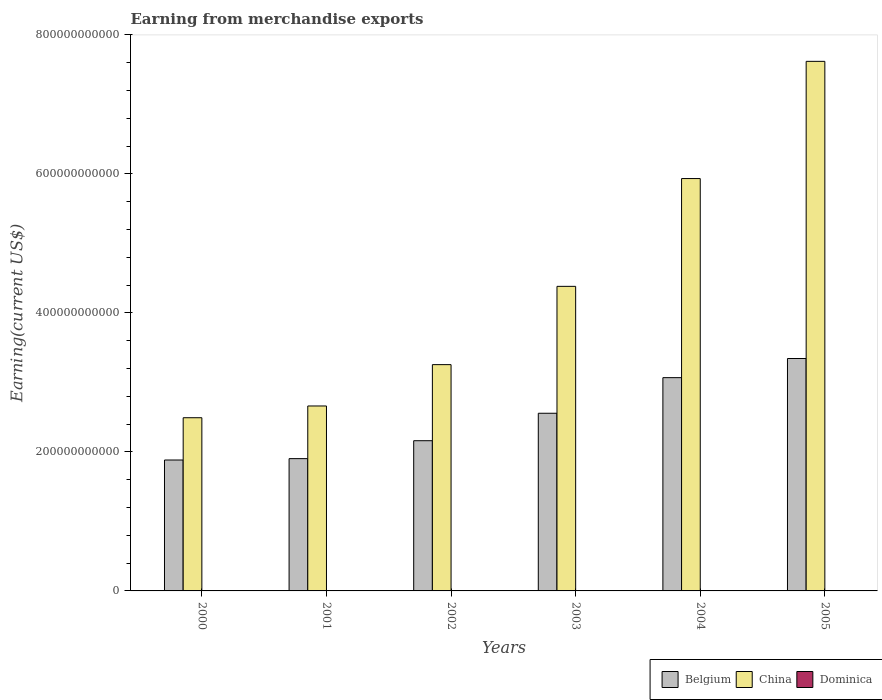How many different coloured bars are there?
Your answer should be compact. 3. How many groups of bars are there?
Give a very brief answer. 6. How many bars are there on the 2nd tick from the left?
Keep it short and to the point. 3. In how many cases, is the number of bars for a given year not equal to the number of legend labels?
Provide a short and direct response. 0. What is the amount earned from merchandise exports in China in 2001?
Your answer should be compact. 2.66e+11. Across all years, what is the maximum amount earned from merchandise exports in Dominica?
Give a very brief answer. 5.30e+07. Across all years, what is the minimum amount earned from merchandise exports in China?
Ensure brevity in your answer.  2.49e+11. In which year was the amount earned from merchandise exports in Belgium minimum?
Offer a terse response. 2000. What is the total amount earned from merchandise exports in Dominica in the graph?
Offer a terse response. 2.64e+08. What is the difference between the amount earned from merchandise exports in China in 2001 and that in 2005?
Give a very brief answer. -4.96e+11. What is the difference between the amount earned from merchandise exports in Belgium in 2001 and the amount earned from merchandise exports in Dominica in 2004?
Give a very brief answer. 1.90e+11. What is the average amount earned from merchandise exports in China per year?
Give a very brief answer. 4.39e+11. In the year 2002, what is the difference between the amount earned from merchandise exports in Dominica and amount earned from merchandise exports in Belgium?
Keep it short and to the point. -2.16e+11. What is the ratio of the amount earned from merchandise exports in Belgium in 2000 to that in 2005?
Keep it short and to the point. 0.56. What is the difference between the highest and the second highest amount earned from merchandise exports in Belgium?
Your answer should be very brief. 2.75e+1. What is the difference between the highest and the lowest amount earned from merchandise exports in China?
Provide a succinct answer. 5.13e+11. In how many years, is the amount earned from merchandise exports in Belgium greater than the average amount earned from merchandise exports in Belgium taken over all years?
Provide a succinct answer. 3. Is the sum of the amount earned from merchandise exports in China in 2001 and 2003 greater than the maximum amount earned from merchandise exports in Dominica across all years?
Ensure brevity in your answer.  Yes. What does the 3rd bar from the left in 2004 represents?
Keep it short and to the point. Dominica. What does the 3rd bar from the right in 2000 represents?
Give a very brief answer. Belgium. How many bars are there?
Your response must be concise. 18. How many years are there in the graph?
Make the answer very short. 6. What is the difference between two consecutive major ticks on the Y-axis?
Your answer should be very brief. 2.00e+11. Are the values on the major ticks of Y-axis written in scientific E-notation?
Your answer should be compact. No. Does the graph contain grids?
Give a very brief answer. No. Where does the legend appear in the graph?
Provide a short and direct response. Bottom right. How many legend labels are there?
Offer a terse response. 3. What is the title of the graph?
Provide a succinct answer. Earning from merchandise exports. What is the label or title of the Y-axis?
Offer a terse response. Earning(current US$). What is the Earning(current US$) of Belgium in 2000?
Your answer should be very brief. 1.88e+11. What is the Earning(current US$) of China in 2000?
Your answer should be very brief. 2.49e+11. What is the Earning(current US$) in Dominica in 2000?
Your response must be concise. 5.30e+07. What is the Earning(current US$) of Belgium in 2001?
Make the answer very short. 1.90e+11. What is the Earning(current US$) of China in 2001?
Keep it short and to the point. 2.66e+11. What is the Earning(current US$) in Dominica in 2001?
Your answer should be compact. 4.40e+07. What is the Earning(current US$) of Belgium in 2002?
Offer a very short reply. 2.16e+11. What is the Earning(current US$) of China in 2002?
Provide a succinct answer. 3.26e+11. What is the Earning(current US$) of Dominica in 2002?
Your answer should be very brief. 4.30e+07. What is the Earning(current US$) in Belgium in 2003?
Keep it short and to the point. 2.56e+11. What is the Earning(current US$) of China in 2003?
Offer a terse response. 4.38e+11. What is the Earning(current US$) in Dominica in 2003?
Provide a short and direct response. 4.00e+07. What is the Earning(current US$) of Belgium in 2004?
Provide a short and direct response. 3.07e+11. What is the Earning(current US$) of China in 2004?
Provide a short and direct response. 5.93e+11. What is the Earning(current US$) in Dominica in 2004?
Make the answer very short. 4.20e+07. What is the Earning(current US$) in Belgium in 2005?
Offer a terse response. 3.34e+11. What is the Earning(current US$) in China in 2005?
Offer a terse response. 7.62e+11. What is the Earning(current US$) of Dominica in 2005?
Offer a very short reply. 4.18e+07. Across all years, what is the maximum Earning(current US$) in Belgium?
Offer a terse response. 3.34e+11. Across all years, what is the maximum Earning(current US$) of China?
Your answer should be compact. 7.62e+11. Across all years, what is the maximum Earning(current US$) of Dominica?
Make the answer very short. 5.30e+07. Across all years, what is the minimum Earning(current US$) in Belgium?
Provide a short and direct response. 1.88e+11. Across all years, what is the minimum Earning(current US$) in China?
Your answer should be compact. 2.49e+11. Across all years, what is the minimum Earning(current US$) in Dominica?
Ensure brevity in your answer.  4.00e+07. What is the total Earning(current US$) of Belgium in the graph?
Provide a succinct answer. 1.49e+12. What is the total Earning(current US$) in China in the graph?
Give a very brief answer. 2.63e+12. What is the total Earning(current US$) of Dominica in the graph?
Provide a succinct answer. 2.64e+08. What is the difference between the Earning(current US$) of Belgium in 2000 and that in 2001?
Give a very brief answer. -1.98e+09. What is the difference between the Earning(current US$) in China in 2000 and that in 2001?
Ensure brevity in your answer.  -1.69e+1. What is the difference between the Earning(current US$) in Dominica in 2000 and that in 2001?
Your answer should be very brief. 9.00e+06. What is the difference between the Earning(current US$) of Belgium in 2000 and that in 2002?
Your answer should be very brief. -2.78e+1. What is the difference between the Earning(current US$) of China in 2000 and that in 2002?
Your answer should be very brief. -7.64e+1. What is the difference between the Earning(current US$) of Dominica in 2000 and that in 2002?
Your answer should be compact. 1.00e+07. What is the difference between the Earning(current US$) of Belgium in 2000 and that in 2003?
Provide a succinct answer. -6.72e+1. What is the difference between the Earning(current US$) in China in 2000 and that in 2003?
Your answer should be compact. -1.89e+11. What is the difference between the Earning(current US$) of Dominica in 2000 and that in 2003?
Ensure brevity in your answer.  1.30e+07. What is the difference between the Earning(current US$) in Belgium in 2000 and that in 2004?
Offer a very short reply. -1.18e+11. What is the difference between the Earning(current US$) in China in 2000 and that in 2004?
Ensure brevity in your answer.  -3.44e+11. What is the difference between the Earning(current US$) in Dominica in 2000 and that in 2004?
Your response must be concise. 1.10e+07. What is the difference between the Earning(current US$) in Belgium in 2000 and that in 2005?
Offer a very short reply. -1.46e+11. What is the difference between the Earning(current US$) in China in 2000 and that in 2005?
Keep it short and to the point. -5.13e+11. What is the difference between the Earning(current US$) in Dominica in 2000 and that in 2005?
Make the answer very short. 1.12e+07. What is the difference between the Earning(current US$) in Belgium in 2001 and that in 2002?
Keep it short and to the point. -2.58e+1. What is the difference between the Earning(current US$) in China in 2001 and that in 2002?
Offer a very short reply. -5.95e+1. What is the difference between the Earning(current US$) in Dominica in 2001 and that in 2002?
Offer a terse response. 1.00e+06. What is the difference between the Earning(current US$) in Belgium in 2001 and that in 2003?
Make the answer very short. -6.53e+1. What is the difference between the Earning(current US$) in China in 2001 and that in 2003?
Your answer should be compact. -1.72e+11. What is the difference between the Earning(current US$) in Dominica in 2001 and that in 2003?
Your answer should be compact. 4.00e+06. What is the difference between the Earning(current US$) in Belgium in 2001 and that in 2004?
Make the answer very short. -1.17e+11. What is the difference between the Earning(current US$) of China in 2001 and that in 2004?
Your answer should be compact. -3.27e+11. What is the difference between the Earning(current US$) of Dominica in 2001 and that in 2004?
Keep it short and to the point. 2.00e+06. What is the difference between the Earning(current US$) of Belgium in 2001 and that in 2005?
Your response must be concise. -1.44e+11. What is the difference between the Earning(current US$) of China in 2001 and that in 2005?
Ensure brevity in your answer.  -4.96e+11. What is the difference between the Earning(current US$) of Dominica in 2001 and that in 2005?
Offer a terse response. 2.22e+06. What is the difference between the Earning(current US$) in Belgium in 2002 and that in 2003?
Provide a short and direct response. -3.95e+1. What is the difference between the Earning(current US$) of China in 2002 and that in 2003?
Your response must be concise. -1.13e+11. What is the difference between the Earning(current US$) in Dominica in 2002 and that in 2003?
Your response must be concise. 3.00e+06. What is the difference between the Earning(current US$) of Belgium in 2002 and that in 2004?
Provide a short and direct response. -9.07e+1. What is the difference between the Earning(current US$) of China in 2002 and that in 2004?
Provide a succinct answer. -2.68e+11. What is the difference between the Earning(current US$) in Dominica in 2002 and that in 2004?
Provide a succinct answer. 1.00e+06. What is the difference between the Earning(current US$) of Belgium in 2002 and that in 2005?
Provide a succinct answer. -1.18e+11. What is the difference between the Earning(current US$) in China in 2002 and that in 2005?
Give a very brief answer. -4.36e+11. What is the difference between the Earning(current US$) of Dominica in 2002 and that in 2005?
Your answer should be compact. 1.22e+06. What is the difference between the Earning(current US$) in Belgium in 2003 and that in 2004?
Provide a short and direct response. -5.12e+1. What is the difference between the Earning(current US$) in China in 2003 and that in 2004?
Provide a short and direct response. -1.55e+11. What is the difference between the Earning(current US$) in Dominica in 2003 and that in 2004?
Provide a succinct answer. -1.99e+06. What is the difference between the Earning(current US$) in Belgium in 2003 and that in 2005?
Provide a short and direct response. -7.88e+1. What is the difference between the Earning(current US$) in China in 2003 and that in 2005?
Offer a very short reply. -3.24e+11. What is the difference between the Earning(current US$) of Dominica in 2003 and that in 2005?
Your answer should be very brief. -1.78e+06. What is the difference between the Earning(current US$) of Belgium in 2004 and that in 2005?
Ensure brevity in your answer.  -2.75e+1. What is the difference between the Earning(current US$) in China in 2004 and that in 2005?
Your response must be concise. -1.69e+11. What is the difference between the Earning(current US$) of Dominica in 2004 and that in 2005?
Provide a short and direct response. 2.12e+05. What is the difference between the Earning(current US$) in Belgium in 2000 and the Earning(current US$) in China in 2001?
Make the answer very short. -7.77e+1. What is the difference between the Earning(current US$) in Belgium in 2000 and the Earning(current US$) in Dominica in 2001?
Offer a very short reply. 1.88e+11. What is the difference between the Earning(current US$) in China in 2000 and the Earning(current US$) in Dominica in 2001?
Your response must be concise. 2.49e+11. What is the difference between the Earning(current US$) in Belgium in 2000 and the Earning(current US$) in China in 2002?
Offer a very short reply. -1.37e+11. What is the difference between the Earning(current US$) in Belgium in 2000 and the Earning(current US$) in Dominica in 2002?
Give a very brief answer. 1.88e+11. What is the difference between the Earning(current US$) in China in 2000 and the Earning(current US$) in Dominica in 2002?
Your answer should be compact. 2.49e+11. What is the difference between the Earning(current US$) of Belgium in 2000 and the Earning(current US$) of China in 2003?
Provide a short and direct response. -2.50e+11. What is the difference between the Earning(current US$) in Belgium in 2000 and the Earning(current US$) in Dominica in 2003?
Offer a terse response. 1.88e+11. What is the difference between the Earning(current US$) in China in 2000 and the Earning(current US$) in Dominica in 2003?
Make the answer very short. 2.49e+11. What is the difference between the Earning(current US$) of Belgium in 2000 and the Earning(current US$) of China in 2004?
Your response must be concise. -4.05e+11. What is the difference between the Earning(current US$) in Belgium in 2000 and the Earning(current US$) in Dominica in 2004?
Provide a short and direct response. 1.88e+11. What is the difference between the Earning(current US$) of China in 2000 and the Earning(current US$) of Dominica in 2004?
Offer a terse response. 2.49e+11. What is the difference between the Earning(current US$) in Belgium in 2000 and the Earning(current US$) in China in 2005?
Provide a succinct answer. -5.74e+11. What is the difference between the Earning(current US$) of Belgium in 2000 and the Earning(current US$) of Dominica in 2005?
Keep it short and to the point. 1.88e+11. What is the difference between the Earning(current US$) in China in 2000 and the Earning(current US$) in Dominica in 2005?
Offer a very short reply. 2.49e+11. What is the difference between the Earning(current US$) of Belgium in 2001 and the Earning(current US$) of China in 2002?
Your answer should be compact. -1.35e+11. What is the difference between the Earning(current US$) in Belgium in 2001 and the Earning(current US$) in Dominica in 2002?
Provide a succinct answer. 1.90e+11. What is the difference between the Earning(current US$) of China in 2001 and the Earning(current US$) of Dominica in 2002?
Make the answer very short. 2.66e+11. What is the difference between the Earning(current US$) in Belgium in 2001 and the Earning(current US$) in China in 2003?
Make the answer very short. -2.48e+11. What is the difference between the Earning(current US$) in Belgium in 2001 and the Earning(current US$) in Dominica in 2003?
Give a very brief answer. 1.90e+11. What is the difference between the Earning(current US$) in China in 2001 and the Earning(current US$) in Dominica in 2003?
Make the answer very short. 2.66e+11. What is the difference between the Earning(current US$) in Belgium in 2001 and the Earning(current US$) in China in 2004?
Your answer should be compact. -4.03e+11. What is the difference between the Earning(current US$) in Belgium in 2001 and the Earning(current US$) in Dominica in 2004?
Keep it short and to the point. 1.90e+11. What is the difference between the Earning(current US$) in China in 2001 and the Earning(current US$) in Dominica in 2004?
Your response must be concise. 2.66e+11. What is the difference between the Earning(current US$) of Belgium in 2001 and the Earning(current US$) of China in 2005?
Ensure brevity in your answer.  -5.72e+11. What is the difference between the Earning(current US$) of Belgium in 2001 and the Earning(current US$) of Dominica in 2005?
Make the answer very short. 1.90e+11. What is the difference between the Earning(current US$) in China in 2001 and the Earning(current US$) in Dominica in 2005?
Offer a terse response. 2.66e+11. What is the difference between the Earning(current US$) of Belgium in 2002 and the Earning(current US$) of China in 2003?
Offer a terse response. -2.22e+11. What is the difference between the Earning(current US$) in Belgium in 2002 and the Earning(current US$) in Dominica in 2003?
Give a very brief answer. 2.16e+11. What is the difference between the Earning(current US$) of China in 2002 and the Earning(current US$) of Dominica in 2003?
Make the answer very short. 3.26e+11. What is the difference between the Earning(current US$) of Belgium in 2002 and the Earning(current US$) of China in 2004?
Your answer should be very brief. -3.77e+11. What is the difference between the Earning(current US$) in Belgium in 2002 and the Earning(current US$) in Dominica in 2004?
Your answer should be compact. 2.16e+11. What is the difference between the Earning(current US$) in China in 2002 and the Earning(current US$) in Dominica in 2004?
Your answer should be very brief. 3.26e+11. What is the difference between the Earning(current US$) in Belgium in 2002 and the Earning(current US$) in China in 2005?
Your response must be concise. -5.46e+11. What is the difference between the Earning(current US$) in Belgium in 2002 and the Earning(current US$) in Dominica in 2005?
Give a very brief answer. 2.16e+11. What is the difference between the Earning(current US$) of China in 2002 and the Earning(current US$) of Dominica in 2005?
Your answer should be very brief. 3.26e+11. What is the difference between the Earning(current US$) in Belgium in 2003 and the Earning(current US$) in China in 2004?
Keep it short and to the point. -3.38e+11. What is the difference between the Earning(current US$) in Belgium in 2003 and the Earning(current US$) in Dominica in 2004?
Provide a short and direct response. 2.56e+11. What is the difference between the Earning(current US$) in China in 2003 and the Earning(current US$) in Dominica in 2004?
Offer a terse response. 4.38e+11. What is the difference between the Earning(current US$) in Belgium in 2003 and the Earning(current US$) in China in 2005?
Provide a succinct answer. -5.06e+11. What is the difference between the Earning(current US$) in Belgium in 2003 and the Earning(current US$) in Dominica in 2005?
Ensure brevity in your answer.  2.56e+11. What is the difference between the Earning(current US$) of China in 2003 and the Earning(current US$) of Dominica in 2005?
Ensure brevity in your answer.  4.38e+11. What is the difference between the Earning(current US$) of Belgium in 2004 and the Earning(current US$) of China in 2005?
Make the answer very short. -4.55e+11. What is the difference between the Earning(current US$) of Belgium in 2004 and the Earning(current US$) of Dominica in 2005?
Your response must be concise. 3.07e+11. What is the difference between the Earning(current US$) in China in 2004 and the Earning(current US$) in Dominica in 2005?
Make the answer very short. 5.93e+11. What is the average Earning(current US$) in Belgium per year?
Give a very brief answer. 2.49e+11. What is the average Earning(current US$) of China per year?
Keep it short and to the point. 4.39e+11. What is the average Earning(current US$) in Dominica per year?
Offer a terse response. 4.40e+07. In the year 2000, what is the difference between the Earning(current US$) in Belgium and Earning(current US$) in China?
Keep it short and to the point. -6.08e+1. In the year 2000, what is the difference between the Earning(current US$) in Belgium and Earning(current US$) in Dominica?
Provide a succinct answer. 1.88e+11. In the year 2000, what is the difference between the Earning(current US$) of China and Earning(current US$) of Dominica?
Keep it short and to the point. 2.49e+11. In the year 2001, what is the difference between the Earning(current US$) of Belgium and Earning(current US$) of China?
Your response must be concise. -7.57e+1. In the year 2001, what is the difference between the Earning(current US$) in Belgium and Earning(current US$) in Dominica?
Make the answer very short. 1.90e+11. In the year 2001, what is the difference between the Earning(current US$) of China and Earning(current US$) of Dominica?
Keep it short and to the point. 2.66e+11. In the year 2002, what is the difference between the Earning(current US$) of Belgium and Earning(current US$) of China?
Keep it short and to the point. -1.09e+11. In the year 2002, what is the difference between the Earning(current US$) of Belgium and Earning(current US$) of Dominica?
Make the answer very short. 2.16e+11. In the year 2002, what is the difference between the Earning(current US$) in China and Earning(current US$) in Dominica?
Ensure brevity in your answer.  3.26e+11. In the year 2003, what is the difference between the Earning(current US$) of Belgium and Earning(current US$) of China?
Your response must be concise. -1.83e+11. In the year 2003, what is the difference between the Earning(current US$) in Belgium and Earning(current US$) in Dominica?
Your answer should be very brief. 2.56e+11. In the year 2003, what is the difference between the Earning(current US$) of China and Earning(current US$) of Dominica?
Give a very brief answer. 4.38e+11. In the year 2004, what is the difference between the Earning(current US$) of Belgium and Earning(current US$) of China?
Your answer should be compact. -2.86e+11. In the year 2004, what is the difference between the Earning(current US$) in Belgium and Earning(current US$) in Dominica?
Keep it short and to the point. 3.07e+11. In the year 2004, what is the difference between the Earning(current US$) in China and Earning(current US$) in Dominica?
Give a very brief answer. 5.93e+11. In the year 2005, what is the difference between the Earning(current US$) of Belgium and Earning(current US$) of China?
Offer a terse response. -4.28e+11. In the year 2005, what is the difference between the Earning(current US$) of Belgium and Earning(current US$) of Dominica?
Provide a succinct answer. 3.34e+11. In the year 2005, what is the difference between the Earning(current US$) of China and Earning(current US$) of Dominica?
Your answer should be compact. 7.62e+11. What is the ratio of the Earning(current US$) in Belgium in 2000 to that in 2001?
Provide a succinct answer. 0.99. What is the ratio of the Earning(current US$) of China in 2000 to that in 2001?
Your answer should be very brief. 0.94. What is the ratio of the Earning(current US$) in Dominica in 2000 to that in 2001?
Your response must be concise. 1.2. What is the ratio of the Earning(current US$) of Belgium in 2000 to that in 2002?
Provide a short and direct response. 0.87. What is the ratio of the Earning(current US$) of China in 2000 to that in 2002?
Provide a short and direct response. 0.77. What is the ratio of the Earning(current US$) in Dominica in 2000 to that in 2002?
Your answer should be very brief. 1.23. What is the ratio of the Earning(current US$) of Belgium in 2000 to that in 2003?
Provide a succinct answer. 0.74. What is the ratio of the Earning(current US$) of China in 2000 to that in 2003?
Ensure brevity in your answer.  0.57. What is the ratio of the Earning(current US$) in Dominica in 2000 to that in 2003?
Your answer should be very brief. 1.32. What is the ratio of the Earning(current US$) of Belgium in 2000 to that in 2004?
Your answer should be very brief. 0.61. What is the ratio of the Earning(current US$) in China in 2000 to that in 2004?
Make the answer very short. 0.42. What is the ratio of the Earning(current US$) in Dominica in 2000 to that in 2004?
Provide a succinct answer. 1.26. What is the ratio of the Earning(current US$) of Belgium in 2000 to that in 2005?
Give a very brief answer. 0.56. What is the ratio of the Earning(current US$) of China in 2000 to that in 2005?
Your answer should be compact. 0.33. What is the ratio of the Earning(current US$) of Dominica in 2000 to that in 2005?
Your response must be concise. 1.27. What is the ratio of the Earning(current US$) of Belgium in 2001 to that in 2002?
Give a very brief answer. 0.88. What is the ratio of the Earning(current US$) of China in 2001 to that in 2002?
Offer a terse response. 0.82. What is the ratio of the Earning(current US$) of Dominica in 2001 to that in 2002?
Ensure brevity in your answer.  1.02. What is the ratio of the Earning(current US$) in Belgium in 2001 to that in 2003?
Your answer should be compact. 0.74. What is the ratio of the Earning(current US$) of China in 2001 to that in 2003?
Your answer should be very brief. 0.61. What is the ratio of the Earning(current US$) of Dominica in 2001 to that in 2003?
Provide a succinct answer. 1.1. What is the ratio of the Earning(current US$) in Belgium in 2001 to that in 2004?
Your answer should be compact. 0.62. What is the ratio of the Earning(current US$) in China in 2001 to that in 2004?
Your answer should be very brief. 0.45. What is the ratio of the Earning(current US$) in Dominica in 2001 to that in 2004?
Provide a short and direct response. 1.05. What is the ratio of the Earning(current US$) in Belgium in 2001 to that in 2005?
Your response must be concise. 0.57. What is the ratio of the Earning(current US$) of China in 2001 to that in 2005?
Give a very brief answer. 0.35. What is the ratio of the Earning(current US$) of Dominica in 2001 to that in 2005?
Give a very brief answer. 1.05. What is the ratio of the Earning(current US$) of Belgium in 2002 to that in 2003?
Your response must be concise. 0.85. What is the ratio of the Earning(current US$) in China in 2002 to that in 2003?
Your response must be concise. 0.74. What is the ratio of the Earning(current US$) in Dominica in 2002 to that in 2003?
Your response must be concise. 1.07. What is the ratio of the Earning(current US$) in Belgium in 2002 to that in 2004?
Your answer should be very brief. 0.7. What is the ratio of the Earning(current US$) of China in 2002 to that in 2004?
Your answer should be compact. 0.55. What is the ratio of the Earning(current US$) of Dominica in 2002 to that in 2004?
Give a very brief answer. 1.02. What is the ratio of the Earning(current US$) in Belgium in 2002 to that in 2005?
Your response must be concise. 0.65. What is the ratio of the Earning(current US$) of China in 2002 to that in 2005?
Offer a terse response. 0.43. What is the ratio of the Earning(current US$) of Dominica in 2002 to that in 2005?
Keep it short and to the point. 1.03. What is the ratio of the Earning(current US$) in Belgium in 2003 to that in 2004?
Offer a terse response. 0.83. What is the ratio of the Earning(current US$) in China in 2003 to that in 2004?
Your answer should be compact. 0.74. What is the ratio of the Earning(current US$) of Dominica in 2003 to that in 2004?
Make the answer very short. 0.95. What is the ratio of the Earning(current US$) of Belgium in 2003 to that in 2005?
Provide a short and direct response. 0.76. What is the ratio of the Earning(current US$) in China in 2003 to that in 2005?
Keep it short and to the point. 0.58. What is the ratio of the Earning(current US$) of Dominica in 2003 to that in 2005?
Offer a very short reply. 0.96. What is the ratio of the Earning(current US$) in Belgium in 2004 to that in 2005?
Your response must be concise. 0.92. What is the ratio of the Earning(current US$) of China in 2004 to that in 2005?
Your response must be concise. 0.78. What is the ratio of the Earning(current US$) in Dominica in 2004 to that in 2005?
Offer a terse response. 1.01. What is the difference between the highest and the second highest Earning(current US$) of Belgium?
Provide a short and direct response. 2.75e+1. What is the difference between the highest and the second highest Earning(current US$) of China?
Provide a short and direct response. 1.69e+11. What is the difference between the highest and the second highest Earning(current US$) of Dominica?
Make the answer very short. 9.00e+06. What is the difference between the highest and the lowest Earning(current US$) of Belgium?
Give a very brief answer. 1.46e+11. What is the difference between the highest and the lowest Earning(current US$) of China?
Your response must be concise. 5.13e+11. What is the difference between the highest and the lowest Earning(current US$) in Dominica?
Keep it short and to the point. 1.30e+07. 